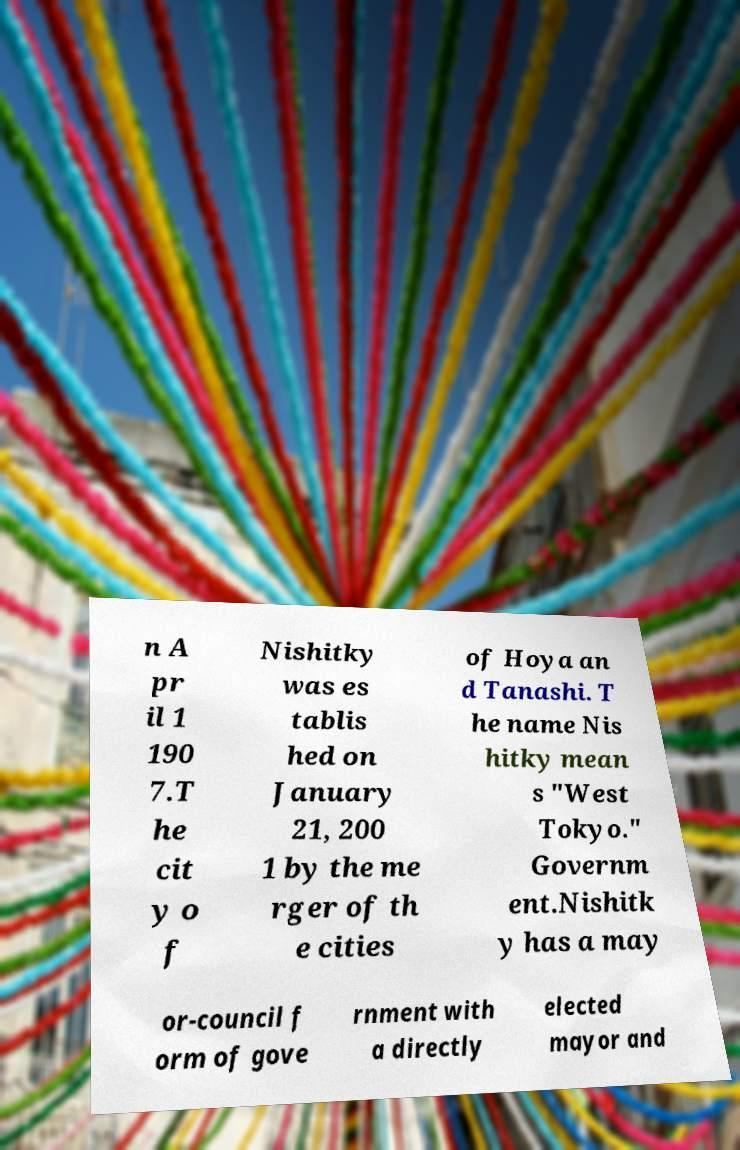Can you read and provide the text displayed in the image?This photo seems to have some interesting text. Can you extract and type it out for me? n A pr il 1 190 7.T he cit y o f Nishitky was es tablis hed on January 21, 200 1 by the me rger of th e cities of Hoya an d Tanashi. T he name Nis hitky mean s "West Tokyo." Governm ent.Nishitk y has a may or-council f orm of gove rnment with a directly elected mayor and 